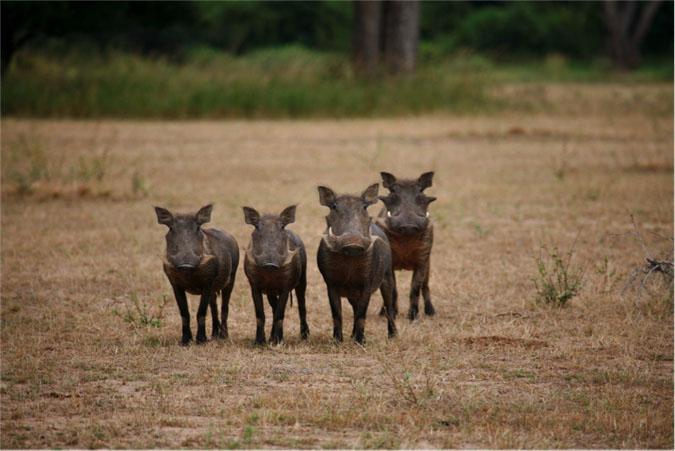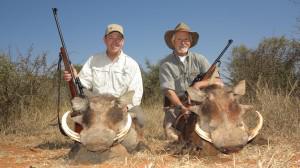The first image is the image on the left, the second image is the image on the right. Analyze the images presented: Is the assertion "There are no more than two warthogs in the image on the right." valid? Answer yes or no. Yes. 